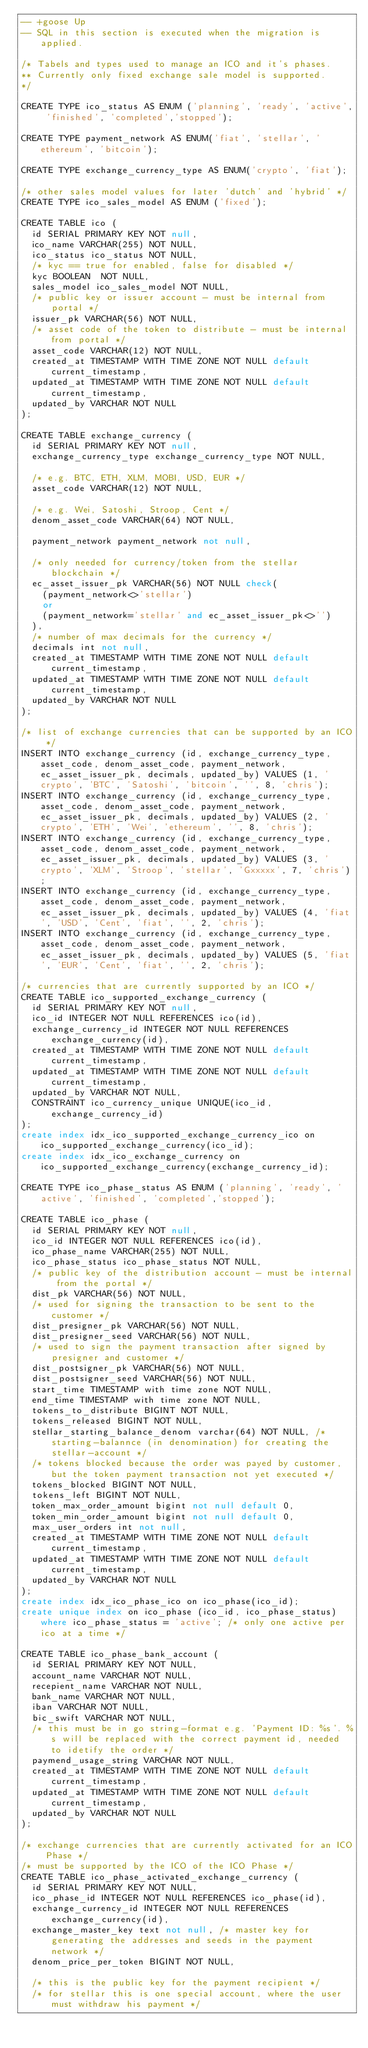<code> <loc_0><loc_0><loc_500><loc_500><_SQL_>-- +goose Up
-- SQL in this section is executed when the migration is applied.

/* Tabels and types used to manage an ICO and it's phases.
** Currently only fixed exchange sale model is supported.
*/

CREATE TYPE ico_status AS ENUM ('planning', 'ready', 'active', 'finished', 'completed','stopped');

CREATE TYPE payment_network AS ENUM('fiat', 'stellar', 'ethereum', 'bitcoin');

CREATE TYPE exchange_currency_type AS ENUM('crypto', 'fiat');

/* other sales model values for later 'dutch' and 'hybrid' */
CREATE TYPE ico_sales_model AS ENUM ('fixed');

CREATE TABLE ico (
  id SERIAL PRIMARY KEY NOT null,
  ico_name VARCHAR(255) NOT NULL,
  ico_status ico_status NOT NULL,
  /* kyc == true for enabled, false for disabled */
  kyc BOOLEAN  NOT NULL, 
  sales_model ico_sales_model NOT NULL,
  /* public key or issuer account - must be internal from portal */
  issuer_pk VARCHAR(56) NOT NULL, 
  /* asset code of the token to distribute - must be internal from portal */
  asset_code VARCHAR(12) NOT NULL,
  created_at TIMESTAMP WITH TIME ZONE NOT NULL default current_timestamp,
  updated_at TIMESTAMP WITH TIME ZONE NOT NULL default current_timestamp,
  updated_by VARCHAR NOT NULL
);

CREATE TABLE exchange_currency (
  id SERIAL PRIMARY KEY NOT null,
  exchange_currency_type exchange_currency_type NOT NULL,

  /* e.g. BTC, ETH, XLM, MOBI, USD, EUR */
  asset_code VARCHAR(12) NOT NULL,

  /* e.g. Wei, Satoshi, Stroop, Cent */
  denom_asset_code VARCHAR(64) NOT NULL,

  payment_network payment_network not null,

  /* only needed for currency/token from the stellar blockchain */
  ec_asset_issuer_pk VARCHAR(56) NOT NULL check(
    (payment_network<>'stellar')
    or
    (payment_network='stellar' and ec_asset_issuer_pk<>'')
  ),
  /* number of max decimals for the currency */
  decimals int not null,
  created_at TIMESTAMP WITH TIME ZONE NOT NULL default current_timestamp,
  updated_at TIMESTAMP WITH TIME ZONE NOT NULL default current_timestamp,
  updated_by VARCHAR NOT NULL
);

/* list of exchange currencies that can be supported by an ICO */
INSERT INTO exchange_currency (id, exchange_currency_type, asset_code, denom_asset_code, payment_network, ec_asset_issuer_pk, decimals, updated_by) VALUES (1, 'crypto', 'BTC', 'Satoshi', 'bitcoin', '', 8, 'chris');
INSERT INTO exchange_currency (id, exchange_currency_type, asset_code, denom_asset_code, payment_network, ec_asset_issuer_pk, decimals, updated_by) VALUES (2, 'crypto', 'ETH', 'Wei', 'ethereum', '', 8, 'chris');
INSERT INTO exchange_currency (id, exchange_currency_type, asset_code, denom_asset_code, payment_network, ec_asset_issuer_pk, decimals, updated_by) VALUES (3, 'crypto', 'XLM', 'Stroop', 'stellar', 'Gxxxxx', 7, 'chris');
INSERT INTO exchange_currency (id, exchange_currency_type, asset_code, denom_asset_code, payment_network, ec_asset_issuer_pk, decimals, updated_by) VALUES (4, 'fiat', 'USD', 'Cent', 'fiat', '', 2, 'chris');
INSERT INTO exchange_currency (id, exchange_currency_type, asset_code, denom_asset_code, payment_network, ec_asset_issuer_pk, decimals, updated_by) VALUES (5, 'fiat', 'EUR', 'Cent', 'fiat', '', 2, 'chris');

/* currencies that are currently supported by an ICO */
CREATE TABLE ico_supported_exchange_currency (
  id SERIAL PRIMARY KEY NOT null,
  ico_id INTEGER NOT NULL REFERENCES ico(id),
  exchange_currency_id INTEGER NOT NULL REFERENCES exchange_currency(id),
  created_at TIMESTAMP WITH TIME ZONE NOT NULL default current_timestamp,
  updated_at TIMESTAMP WITH TIME ZONE NOT NULL default current_timestamp,
  updated_by VARCHAR NOT NULL,
  CONSTRAINT ico_currency_unique UNIQUE(ico_id, exchange_currency_id)
);
create index idx_ico_supported_exchange_currency_ico on ico_supported_exchange_currency(ico_id);
create index idx_ico_exchange_currency on ico_supported_exchange_currency(exchange_currency_id);

CREATE TYPE ico_phase_status AS ENUM ('planning', 'ready', 'active', 'finished', 'completed','stopped');

CREATE TABLE ico_phase (
  id SERIAL PRIMARY KEY NOT null,
  ico_id INTEGER NOT NULL REFERENCES ico(id),
  ico_phase_name VARCHAR(255) NOT NULL,
  ico_phase_status ico_phase_status NOT NULL,
  /* public key of the distribution account - must be internal from the portal */
  dist_pk VARCHAR(56) NOT NULL,  
  /* used for signing the transaction to be sent to the customer */
  dist_presigner_pk VARCHAR(56) NOT NULL,
  dist_presigner_seed VARCHAR(56) NOT NULL,
  /* used to sign the payment transaction after signed by presigner and customer */
  dist_postsigner_pk VARCHAR(56) NOT NULL,
  dist_postsigner_seed VARCHAR(56) NOT NULL,
  start_time TIMESTAMP with time zone NOT NULL,
  end_time TIMESTAMP with time zone NOT NULL,  
  tokens_to_distribute BIGINT NOT NULL,
  tokens_released BIGINT NOT NULL,
  stellar_starting_balance_denom varchar(64) NOT NULL, /*starting-balannce (in denomination) for creating the stellar-account */
  /* tokens blocked because the order was payed by customer, but the token payment transaction not yet executed */
  tokens_blocked BIGINT NOT NULL,
  tokens_left BIGINT NOT NULL,
  token_max_order_amount bigint not null default 0,
  token_min_order_amount bigint not null default 0,
  max_user_orders int not null,
  created_at TIMESTAMP WITH TIME ZONE NOT NULL default current_timestamp,
  updated_at TIMESTAMP WITH TIME ZONE NOT NULL default current_timestamp,
  updated_by VARCHAR NOT NULL
);
create index idx_ico_phase_ico on ico_phase(ico_id);
create unique index on ico_phase (ico_id, ico_phase_status) where ico_phase_status = 'active'; /* only one active per ico at a time */

CREATE TABLE ico_phase_bank_account (
  id SERIAL PRIMARY KEY NOT NULL,
  account_name VARCHAR NOT NULL,
  recepient_name VARCHAR NOT NULL,
  bank_name VARCHAR NOT NULL,
  iban VARCHAR NOT NULL,
  bic_swift VARCHAR NOT NULL,
  /* this must be in go string-format e.g. 'Payment ID: %s'. %s will be replaced with the correct payment id, needed to idetify the order */
  paymend_usage_string VARCHAR NOT NULL,
  created_at TIMESTAMP WITH TIME ZONE NOT NULL default current_timestamp,
  updated_at TIMESTAMP WITH TIME ZONE NOT NULL default current_timestamp,
  updated_by VARCHAR NOT NULL
);

/* exchange currencies that are currently activated for an ICO Phase */
/* must be supported by the ICO of the ICO Phase */
CREATE TABLE ico_phase_activated_exchange_currency (
  id SERIAL PRIMARY KEY NOT NULL,
  ico_phase_id INTEGER NOT NULL REFERENCES ico_phase(id),
  exchange_currency_id INTEGER NOT NULL REFERENCES exchange_currency(id),  
  exchange_master_key text not null, /* master key for generating the addresses and seeds in the payment network */
  denom_price_per_token BIGINT NOT NULL,  

  /* this is the public key for the payment recipient */
  /* for stellar this is one special account, where the user must withdraw his payment */</code> 